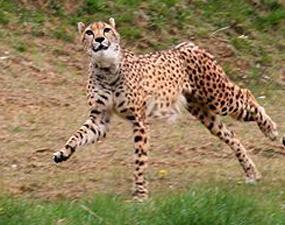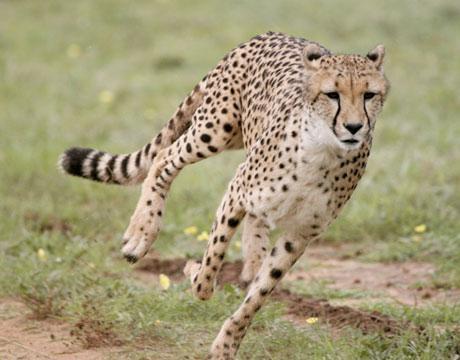The first image is the image on the left, the second image is the image on the right. Assess this claim about the two images: "Each image shows a single spotted wild cat, and each cat is in a similar type of pose.". Correct or not? Answer yes or no. Yes. The first image is the image on the left, the second image is the image on the right. Given the left and right images, does the statement "At least one of the animals is sitting on the ground." hold true? Answer yes or no. No. 